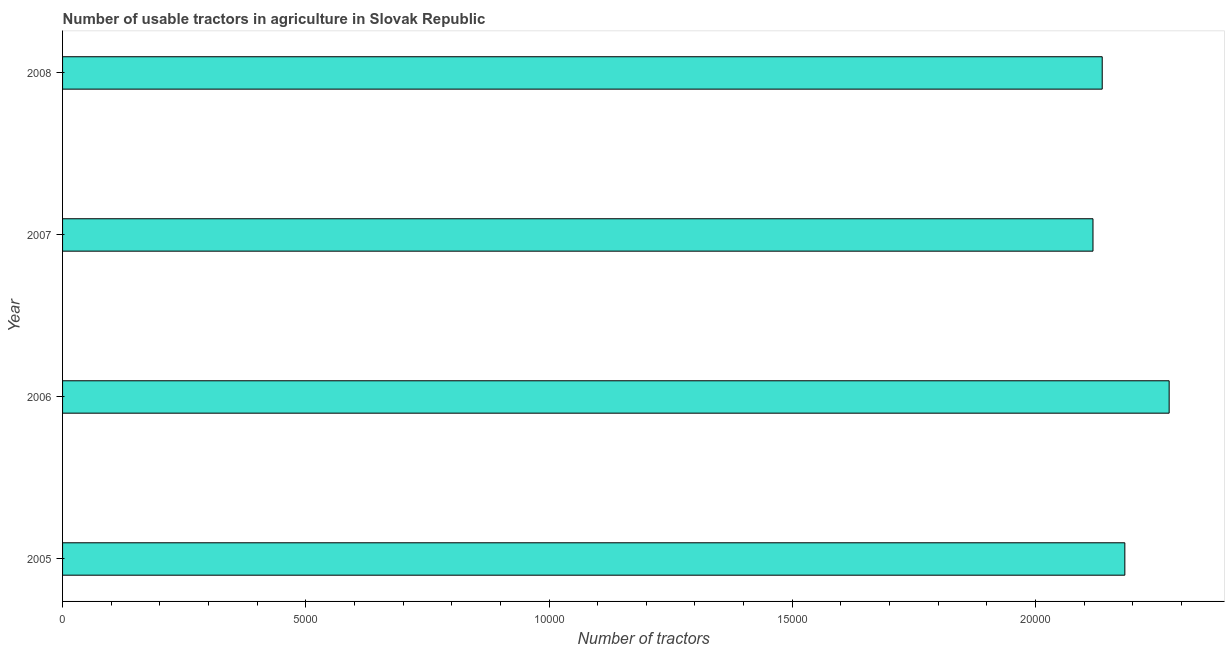Does the graph contain any zero values?
Keep it short and to the point. No. Does the graph contain grids?
Offer a terse response. No. What is the title of the graph?
Offer a very short reply. Number of usable tractors in agriculture in Slovak Republic. What is the label or title of the X-axis?
Your response must be concise. Number of tractors. What is the number of tractors in 2007?
Provide a short and direct response. 2.12e+04. Across all years, what is the maximum number of tractors?
Keep it short and to the point. 2.27e+04. Across all years, what is the minimum number of tractors?
Your answer should be very brief. 2.12e+04. In which year was the number of tractors maximum?
Ensure brevity in your answer.  2006. In which year was the number of tractors minimum?
Your answer should be very brief. 2007. What is the sum of the number of tractors?
Provide a short and direct response. 8.71e+04. What is the difference between the number of tractors in 2007 and 2008?
Give a very brief answer. -190. What is the average number of tractors per year?
Ensure brevity in your answer.  2.18e+04. What is the median number of tractors?
Offer a very short reply. 2.16e+04. Do a majority of the years between 2008 and 2005 (inclusive) have number of tractors greater than 10000 ?
Keep it short and to the point. Yes. Is the number of tractors in 2006 less than that in 2007?
Your answer should be very brief. No. Is the difference between the number of tractors in 2007 and 2008 greater than the difference between any two years?
Provide a short and direct response. No. What is the difference between the highest and the second highest number of tractors?
Ensure brevity in your answer.  911. What is the difference between the highest and the lowest number of tractors?
Your response must be concise. 1566. Are all the bars in the graph horizontal?
Ensure brevity in your answer.  Yes. How many years are there in the graph?
Give a very brief answer. 4. What is the difference between two consecutive major ticks on the X-axis?
Your response must be concise. 5000. Are the values on the major ticks of X-axis written in scientific E-notation?
Offer a very short reply. No. What is the Number of tractors in 2005?
Ensure brevity in your answer.  2.18e+04. What is the Number of tractors in 2006?
Keep it short and to the point. 2.27e+04. What is the Number of tractors of 2007?
Provide a short and direct response. 2.12e+04. What is the Number of tractors in 2008?
Offer a very short reply. 2.14e+04. What is the difference between the Number of tractors in 2005 and 2006?
Keep it short and to the point. -911. What is the difference between the Number of tractors in 2005 and 2007?
Make the answer very short. 655. What is the difference between the Number of tractors in 2005 and 2008?
Provide a short and direct response. 465. What is the difference between the Number of tractors in 2006 and 2007?
Provide a short and direct response. 1566. What is the difference between the Number of tractors in 2006 and 2008?
Offer a terse response. 1376. What is the difference between the Number of tractors in 2007 and 2008?
Make the answer very short. -190. What is the ratio of the Number of tractors in 2005 to that in 2007?
Your response must be concise. 1.03. What is the ratio of the Number of tractors in 2006 to that in 2007?
Offer a terse response. 1.07. What is the ratio of the Number of tractors in 2006 to that in 2008?
Give a very brief answer. 1.06. 